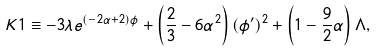Convert formula to latex. <formula><loc_0><loc_0><loc_500><loc_500>K 1 \equiv - 3 \lambda e ^ { ( - 2 \alpha + 2 ) \phi } + \left ( \frac { 2 } { 3 } - 6 \alpha ^ { 2 } \right ) ( \phi ^ { \prime } ) ^ { 2 } + \left ( 1 - \frac { 9 } { 2 } \alpha \right ) \Lambda ,</formula> 